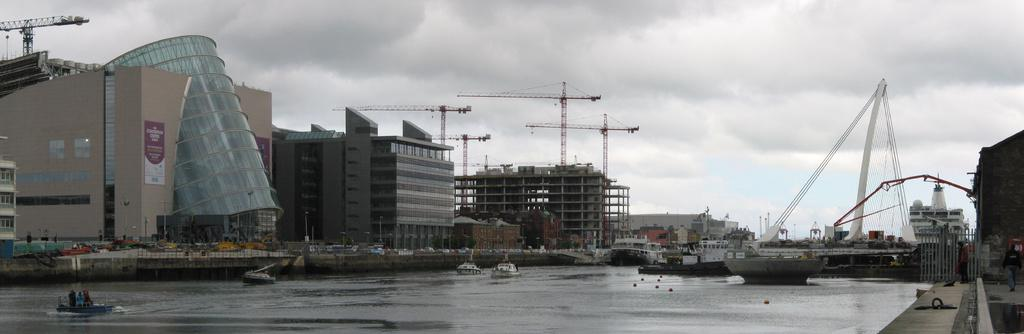What body of water is present in the image? There is a river in the image. What is on the river in the image? There are ships on the river. What can be seen in the background of the image? There is a bridge, buildings, and a construction crane in the background of the image. What is visible in the sky in the image? The sky is visible in the image. What type of apparatus is being used by the sheep in the image? There are no sheep present in the image, and therefore no apparatus can be associated with them. 